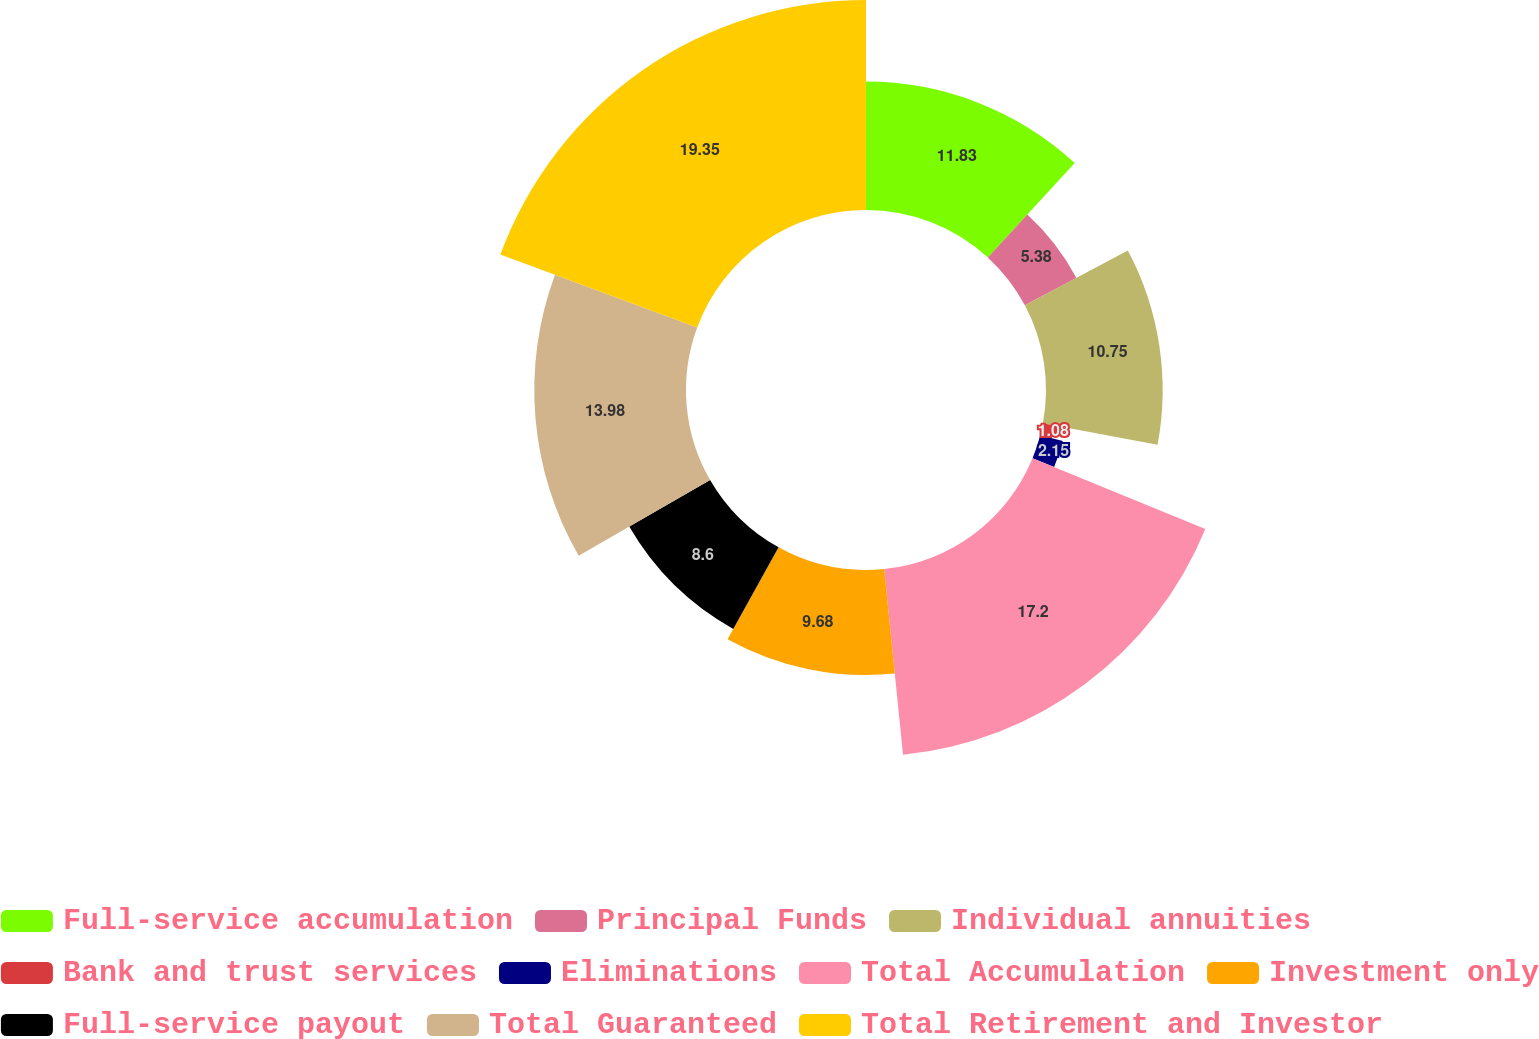Convert chart to OTSL. <chart><loc_0><loc_0><loc_500><loc_500><pie_chart><fcel>Full-service accumulation<fcel>Principal Funds<fcel>Individual annuities<fcel>Bank and trust services<fcel>Eliminations<fcel>Total Accumulation<fcel>Investment only<fcel>Full-service payout<fcel>Total Guaranteed<fcel>Total Retirement and Investor<nl><fcel>11.83%<fcel>5.38%<fcel>10.75%<fcel>1.08%<fcel>2.15%<fcel>17.2%<fcel>9.68%<fcel>8.6%<fcel>13.98%<fcel>19.35%<nl></chart> 